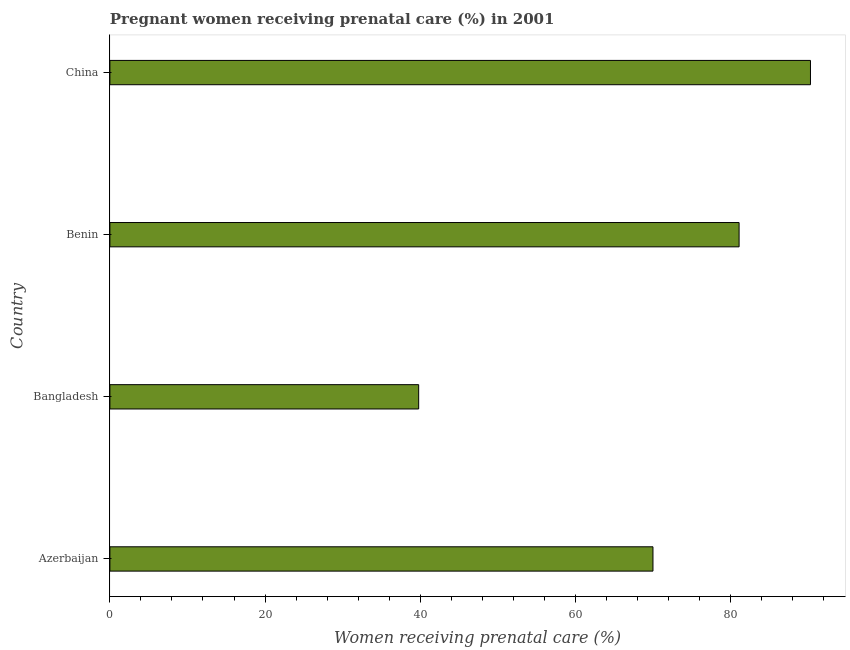Does the graph contain any zero values?
Your response must be concise. No. Does the graph contain grids?
Keep it short and to the point. No. What is the title of the graph?
Ensure brevity in your answer.  Pregnant women receiving prenatal care (%) in 2001. What is the label or title of the X-axis?
Provide a short and direct response. Women receiving prenatal care (%). What is the percentage of pregnant women receiving prenatal care in China?
Provide a short and direct response. 90.3. Across all countries, what is the maximum percentage of pregnant women receiving prenatal care?
Your answer should be compact. 90.3. Across all countries, what is the minimum percentage of pregnant women receiving prenatal care?
Give a very brief answer. 39.8. What is the sum of the percentage of pregnant women receiving prenatal care?
Ensure brevity in your answer.  281.2. What is the difference between the percentage of pregnant women receiving prenatal care in Bangladesh and China?
Your response must be concise. -50.5. What is the average percentage of pregnant women receiving prenatal care per country?
Your answer should be compact. 70.3. What is the median percentage of pregnant women receiving prenatal care?
Your response must be concise. 75.55. What is the ratio of the percentage of pregnant women receiving prenatal care in Azerbaijan to that in Benin?
Your answer should be very brief. 0.86. What is the difference between the highest and the lowest percentage of pregnant women receiving prenatal care?
Your answer should be very brief. 50.5. How many bars are there?
Provide a short and direct response. 4. How many countries are there in the graph?
Your answer should be compact. 4. What is the difference between two consecutive major ticks on the X-axis?
Provide a short and direct response. 20. What is the Women receiving prenatal care (%) of Azerbaijan?
Ensure brevity in your answer.  70. What is the Women receiving prenatal care (%) of Bangladesh?
Offer a terse response. 39.8. What is the Women receiving prenatal care (%) of Benin?
Give a very brief answer. 81.1. What is the Women receiving prenatal care (%) of China?
Provide a short and direct response. 90.3. What is the difference between the Women receiving prenatal care (%) in Azerbaijan and Bangladesh?
Offer a very short reply. 30.2. What is the difference between the Women receiving prenatal care (%) in Azerbaijan and China?
Offer a terse response. -20.3. What is the difference between the Women receiving prenatal care (%) in Bangladesh and Benin?
Keep it short and to the point. -41.3. What is the difference between the Women receiving prenatal care (%) in Bangladesh and China?
Offer a terse response. -50.5. What is the ratio of the Women receiving prenatal care (%) in Azerbaijan to that in Bangladesh?
Your answer should be very brief. 1.76. What is the ratio of the Women receiving prenatal care (%) in Azerbaijan to that in Benin?
Ensure brevity in your answer.  0.86. What is the ratio of the Women receiving prenatal care (%) in Azerbaijan to that in China?
Give a very brief answer. 0.78. What is the ratio of the Women receiving prenatal care (%) in Bangladesh to that in Benin?
Offer a very short reply. 0.49. What is the ratio of the Women receiving prenatal care (%) in Bangladesh to that in China?
Provide a succinct answer. 0.44. What is the ratio of the Women receiving prenatal care (%) in Benin to that in China?
Give a very brief answer. 0.9. 